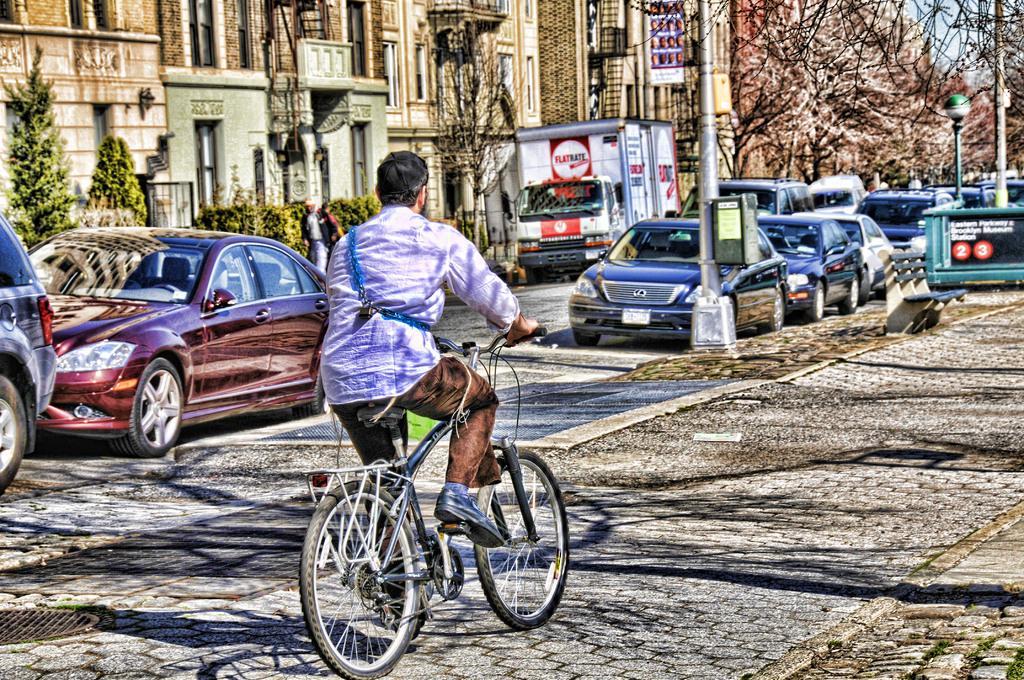How would you summarize this image in a sentence or two? In this image the person is riding the bicycle on the left side there are so many cars is parked and one truck is also there and behind the cars there are some buildings and trees are there and some current polls are also there on the path and the background is sunny. 